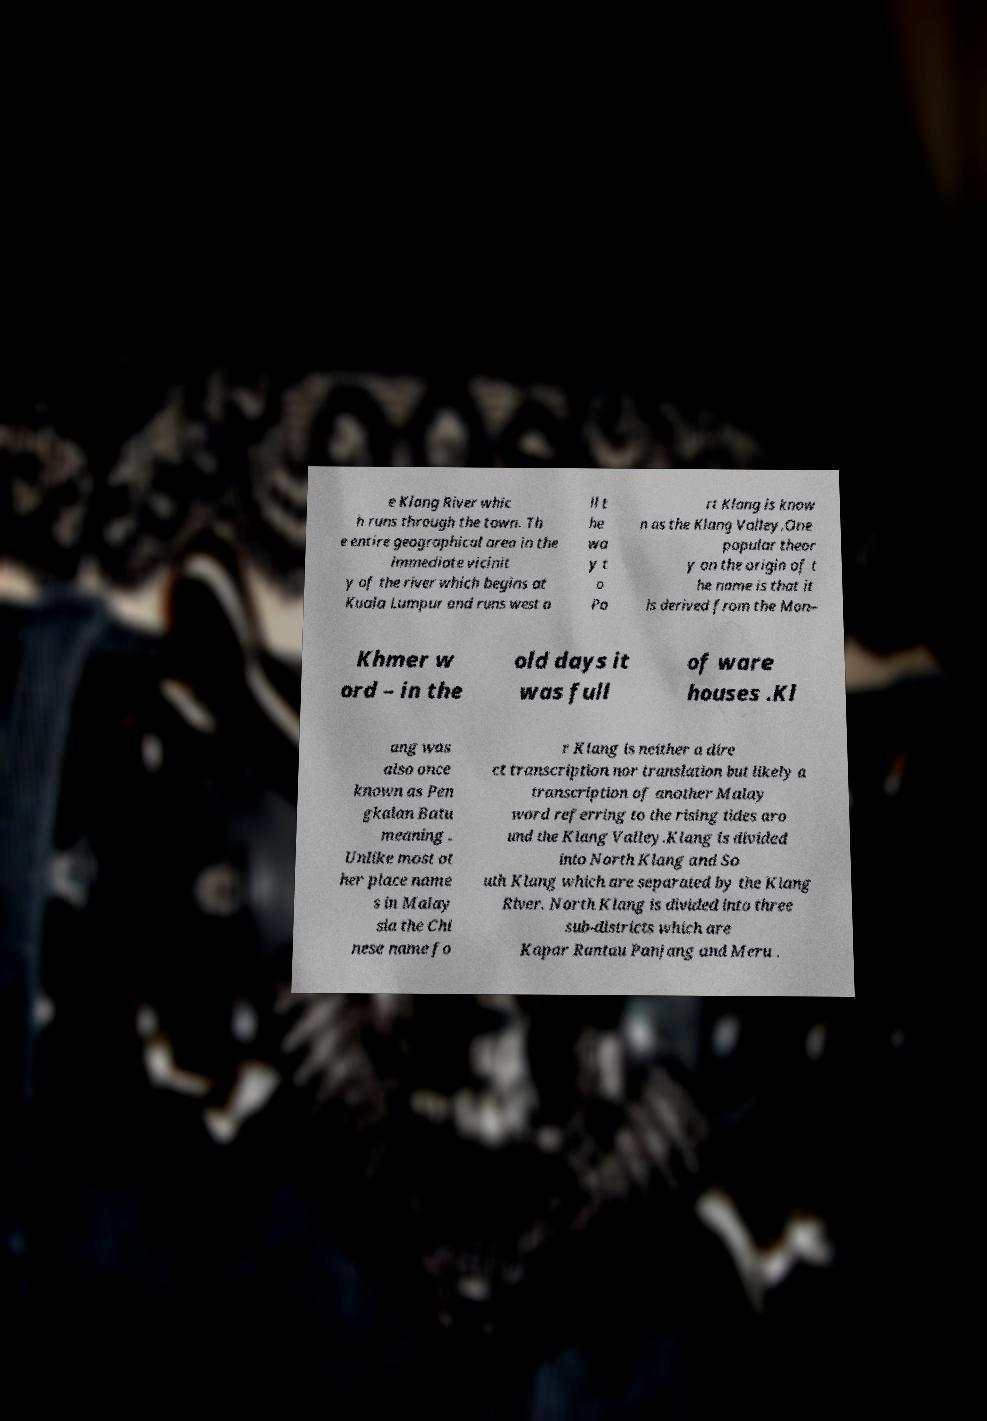Please identify and transcribe the text found in this image. e Klang River whic h runs through the town. Th e entire geographical area in the immediate vicinit y of the river which begins at Kuala Lumpur and runs west a ll t he wa y t o Po rt Klang is know n as the Klang Valley.One popular theor y on the origin of t he name is that it is derived from the Mon– Khmer w ord – in the old days it was full of ware houses .Kl ang was also once known as Pen gkalan Batu meaning . Unlike most ot her place name s in Malay sia the Chi nese name fo r Klang is neither a dire ct transcription nor translation but likely a transcription of another Malay word referring to the rising tides aro und the Klang Valley.Klang is divided into North Klang and So uth Klang which are separated by the Klang River. North Klang is divided into three sub-districts which are Kapar Rantau Panjang and Meru . 